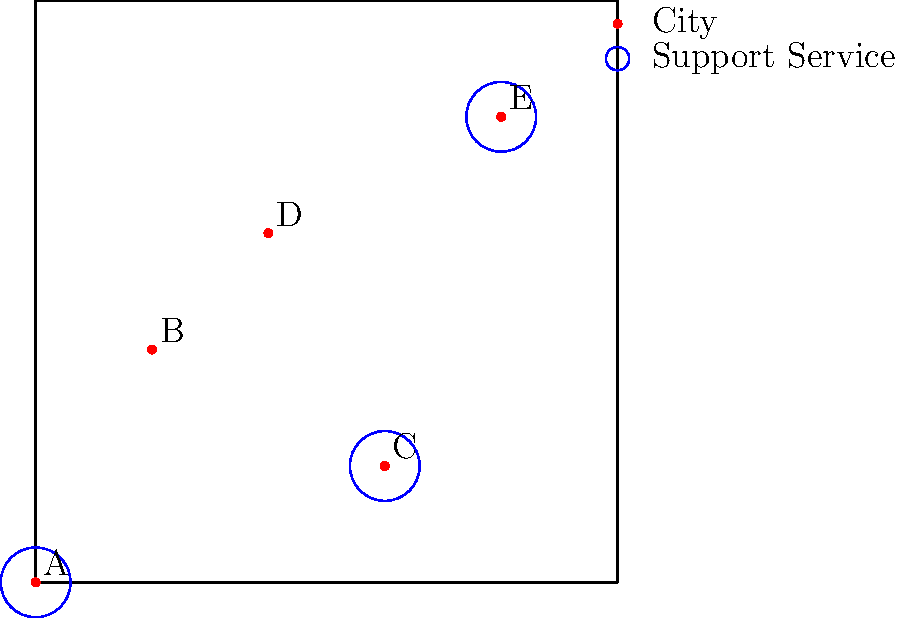The map shows the distribution of support services for formerly incarcerated individuals across five cities (A, B, C, D, and E). Blue circles represent the presence of support services. Based on this information, what percentage of the cities have support services available, and which city would be the best location to establish a new support service to maximize coverage? To answer this question, we need to follow these steps:

1. Count the total number of cities:
   There are 5 cities: A, B, C, D, and E.

2. Count the number of cities with support services:
   Cities with blue circles (support services) are A, C, and E.
   Total cities with services = 3

3. Calculate the percentage of cities with support services:
   Percentage = (Cities with services / Total cities) × 100
   Percentage = (3 / 5) × 100 = 60%

4. Determine the best location for a new support service:
   - Cities A, C, and E already have services.
   - Cities B and D lack services.
   - To maximize coverage, we should choose the city that is farthest from existing services.
   - City D appears to be farther from existing services compared to City B.

Therefore, City D would be the best location to establish a new support service to maximize coverage.
Answer: 60%; City D 